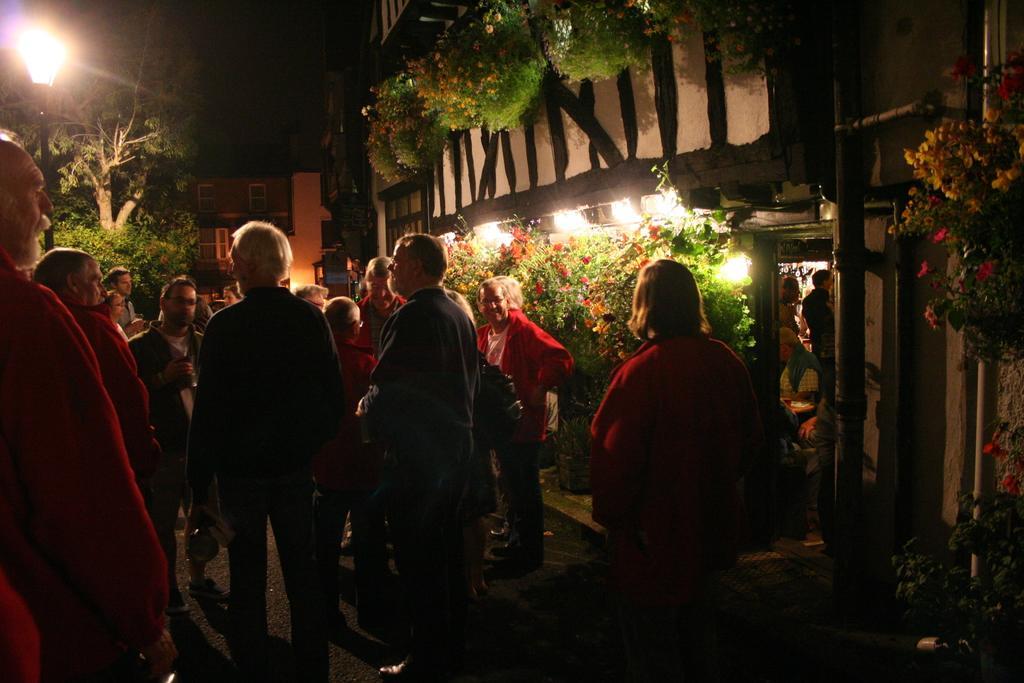How would you summarize this image in a sentence or two? In this picture we can see a group of people on the ground, here we can see plants with flowers, buildings, trees, electric pole, lights and in the background we can see it is dark. 